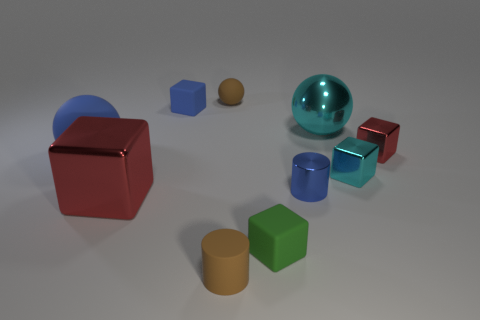The other matte thing that is the same color as the large matte object is what shape?
Your answer should be compact. Cube. There is a small matte sphere; is its color the same as the thing that is in front of the green block?
Your answer should be very brief. Yes. How many other objects are there of the same size as the green matte cube?
Make the answer very short. 6. There is a red object right of the small blue metal object; is its shape the same as the blue rubber thing that is behind the big blue rubber thing?
Offer a terse response. Yes. There is a large blue rubber ball; are there any things behind it?
Provide a succinct answer. Yes. What color is the other rubber object that is the same shape as the big blue rubber object?
Give a very brief answer. Brown. Is there any other thing that has the same shape as the green object?
Your answer should be compact. Yes. There is a large thing that is in front of the tiny shiny cylinder; what is it made of?
Make the answer very short. Metal. There is a blue rubber object that is the same shape as the large cyan metal object; what size is it?
Provide a short and direct response. Large. What number of small balls have the same material as the big blue thing?
Offer a terse response. 1. 